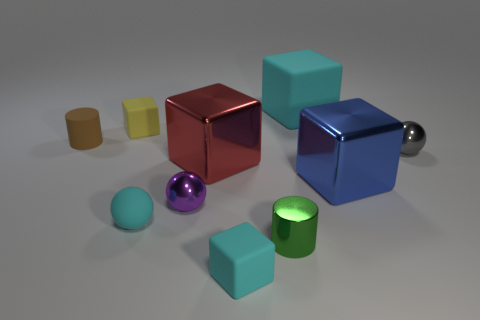Subtract all yellow cubes. How many cubes are left? 4 Subtract all big red shiny blocks. How many blocks are left? 4 Subtract all gray cubes. Subtract all cyan cylinders. How many cubes are left? 5 Subtract all balls. How many objects are left? 7 Subtract 0 red cylinders. How many objects are left? 10 Subtract all tiny cyan matte things. Subtract all tiny green cylinders. How many objects are left? 7 Add 7 small matte cylinders. How many small matte cylinders are left? 8 Add 2 rubber balls. How many rubber balls exist? 3 